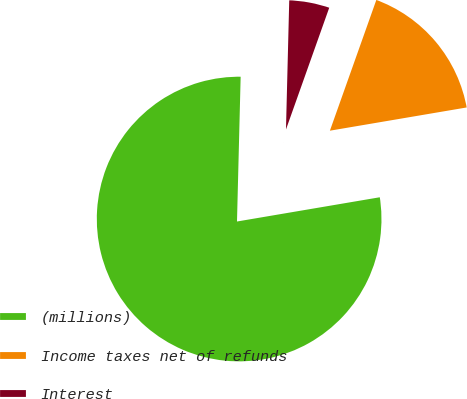Convert chart. <chart><loc_0><loc_0><loc_500><loc_500><pie_chart><fcel>(millions)<fcel>Income taxes net of refunds<fcel>Interest<nl><fcel>78.08%<fcel>16.89%<fcel>5.03%<nl></chart> 